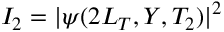Convert formula to latex. <formula><loc_0><loc_0><loc_500><loc_500>I _ { 2 } = | \psi ( 2 L _ { T } , Y , T _ { 2 } ) | ^ { 2 }</formula> 